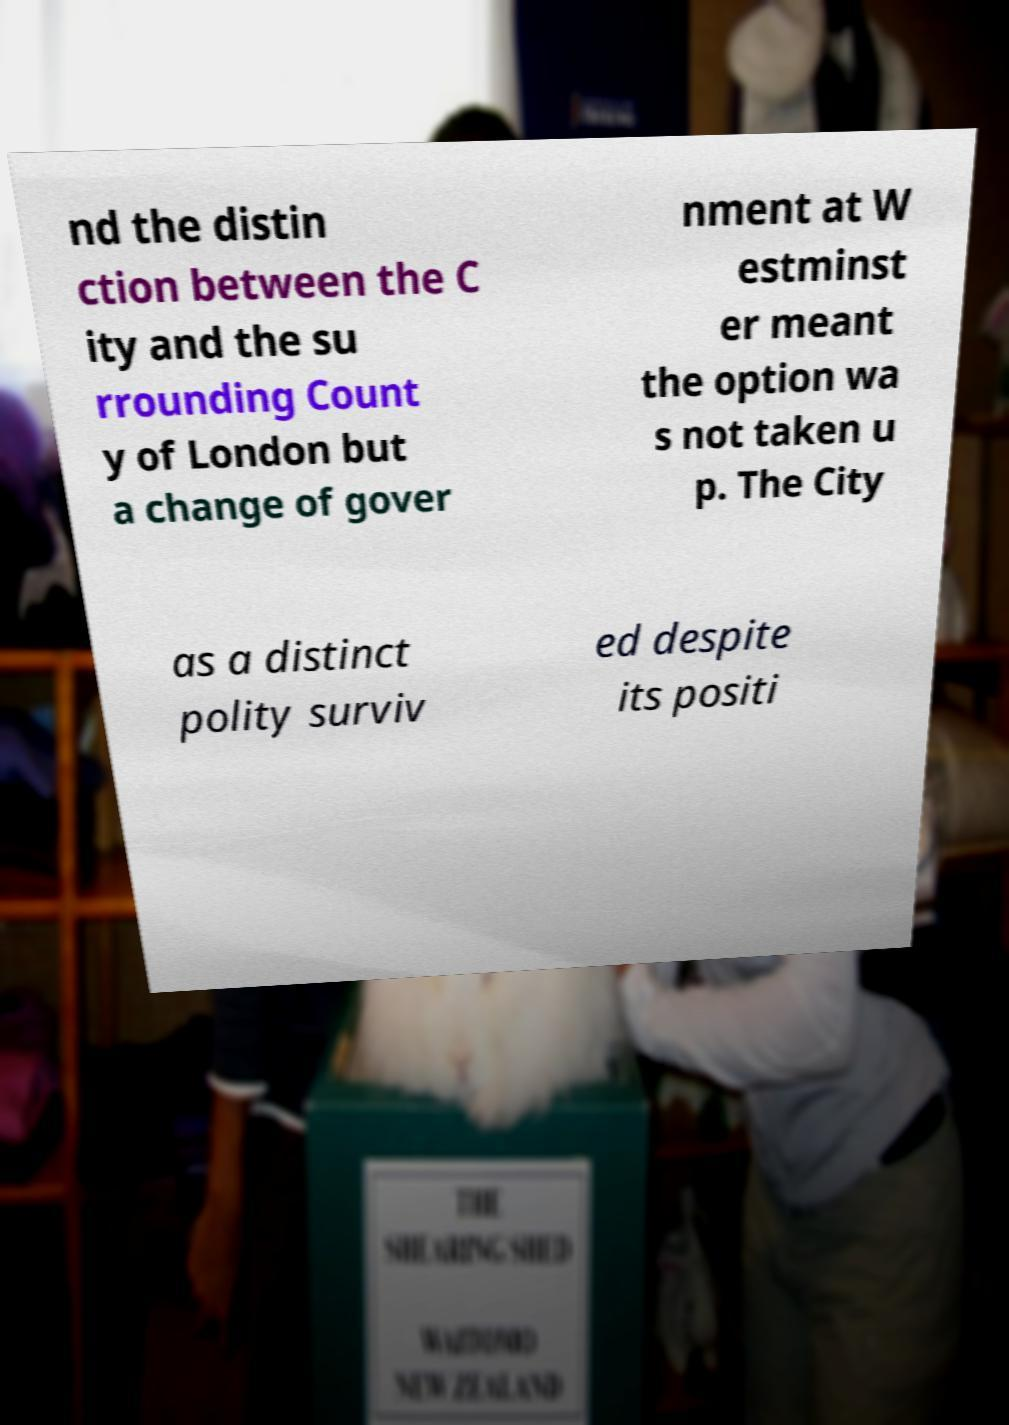Could you extract and type out the text from this image? nd the distin ction between the C ity and the su rrounding Count y of London but a change of gover nment at W estminst er meant the option wa s not taken u p. The City as a distinct polity surviv ed despite its positi 